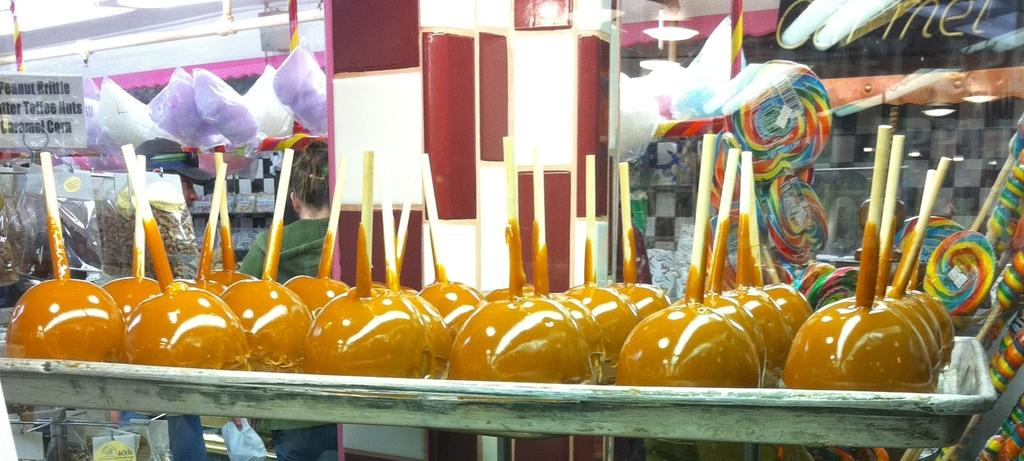What is the main subject of the image? The main subject of the image is a group of lollipops. How are the lollipops arranged in the image? The lollipops are placed in a tray. What can be seen in the background of the image? In the background of the image, there are lights, rods, posters, packets, and a woman. What type of love can be seen in the image? There is no love present in the image; it features a group of lollipops arranged in a tray with various elements in the background. How many drops can be seen falling from the rods in the image? There are no drops visible in the image; only lights, rods, posters, packets, and a woman can be seen in the background. 